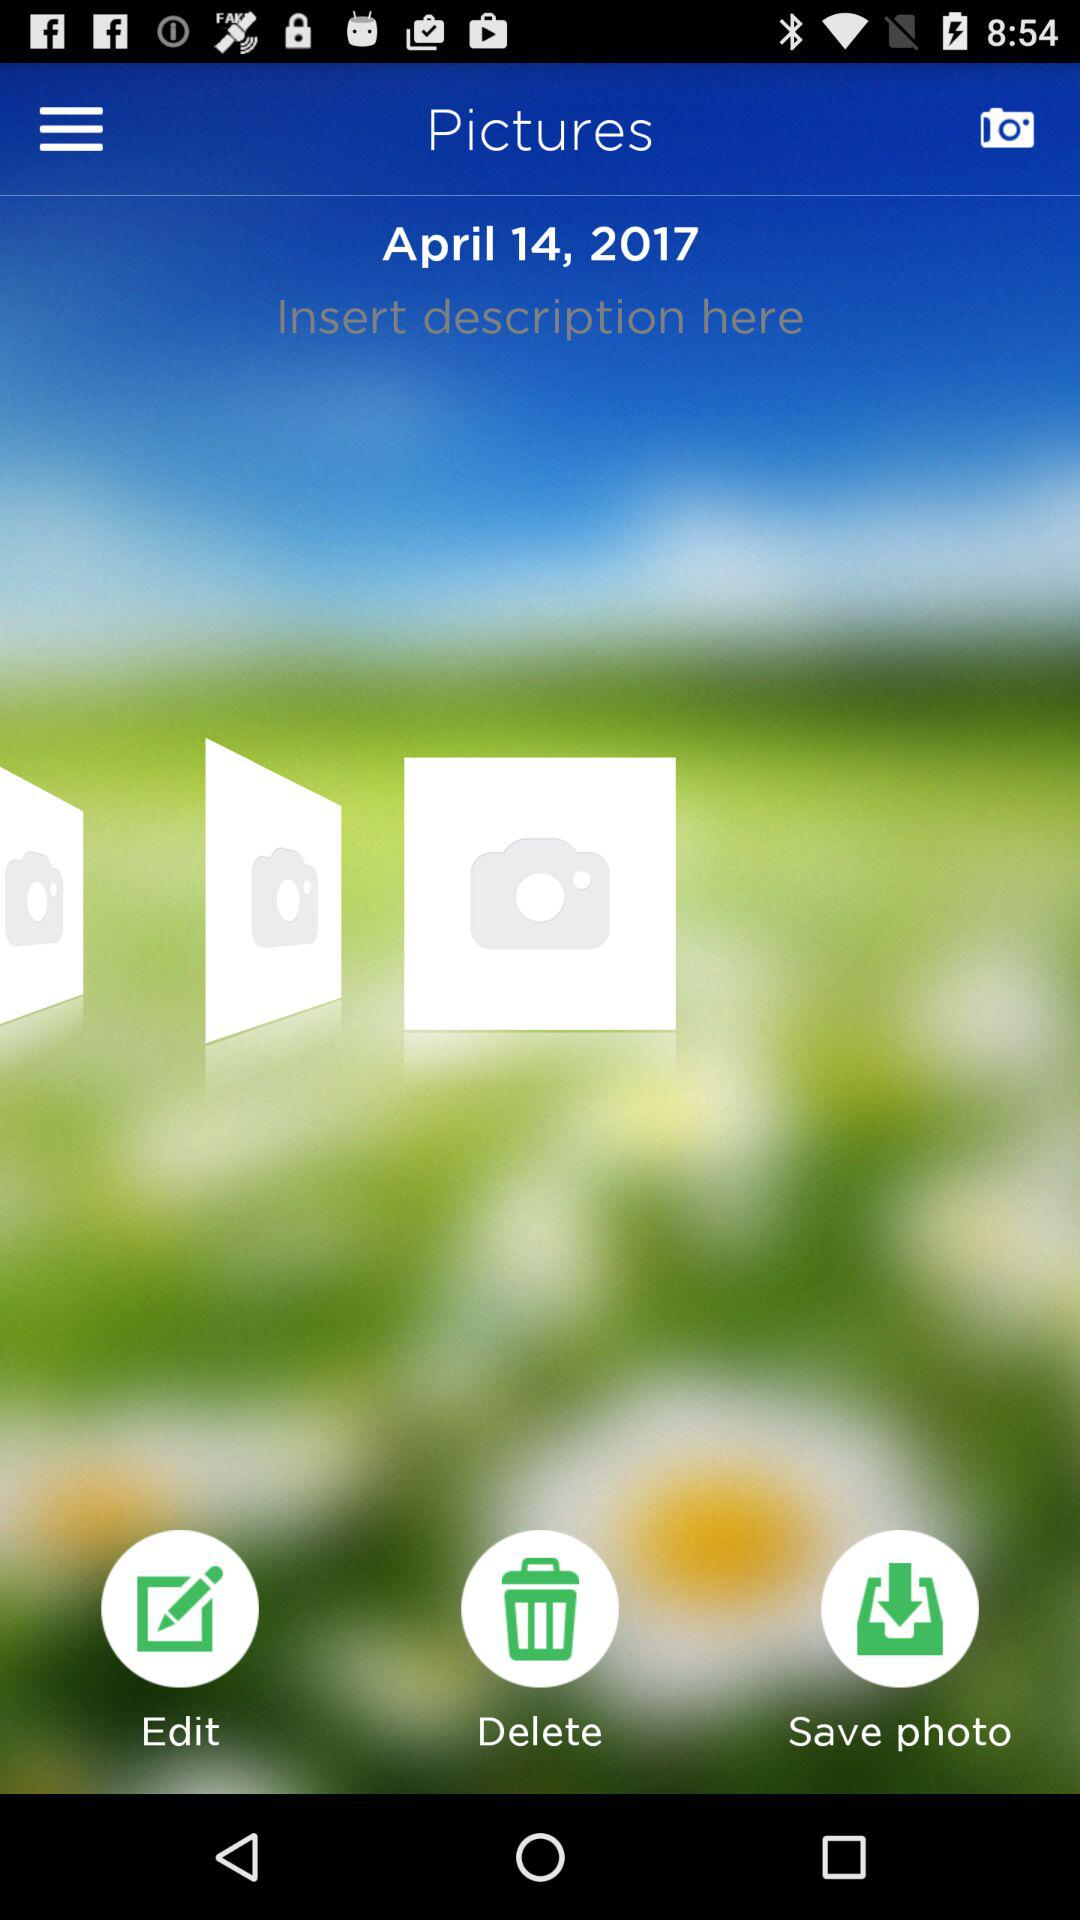What is the given date? The given date is April 14, 2017. 